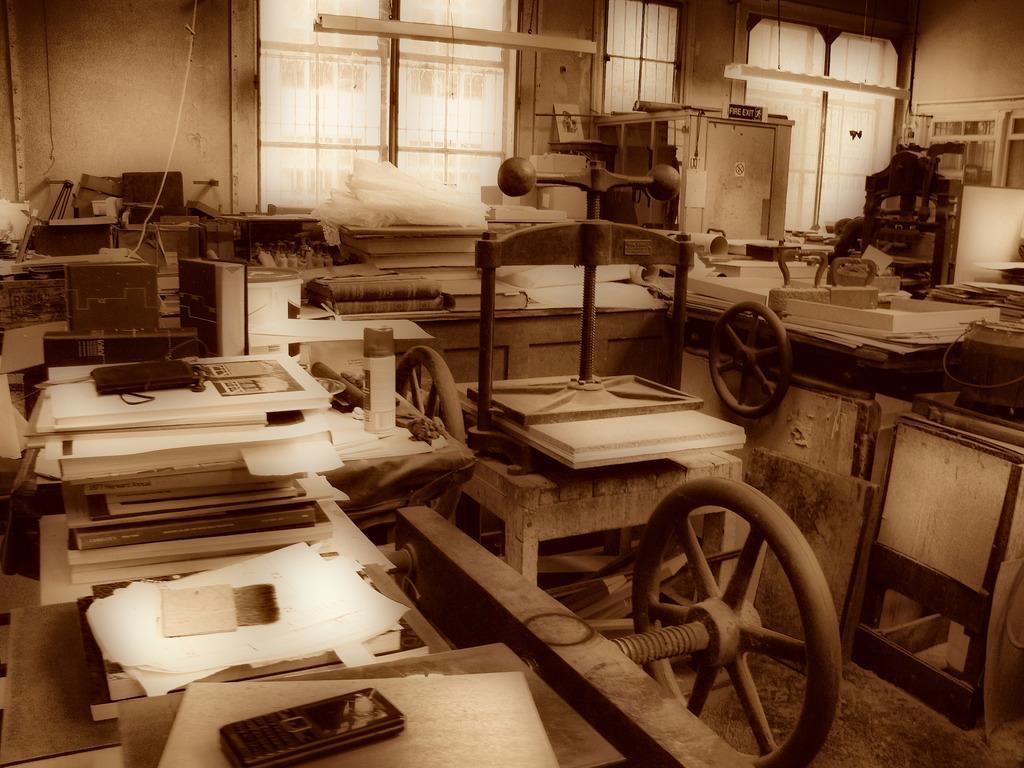In one or two sentences, can you explain what this image depicts? In this image I can see few machines, few wooden objects, papers, mobiles phone and few objects around. Back I can see the windows and the wall. 